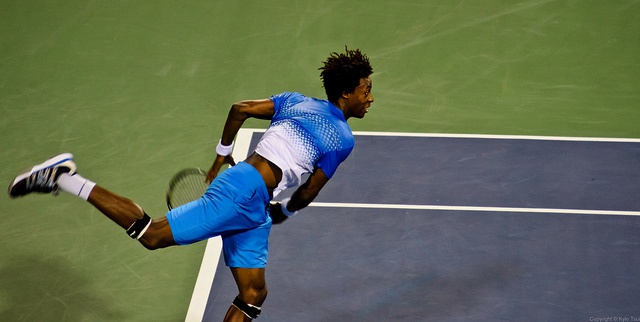Describe the objects in this image and their specific colors. I can see people in darkgreen, black, blue, lightgray, and maroon tones and tennis racket in darkgreen and olive tones in this image. 